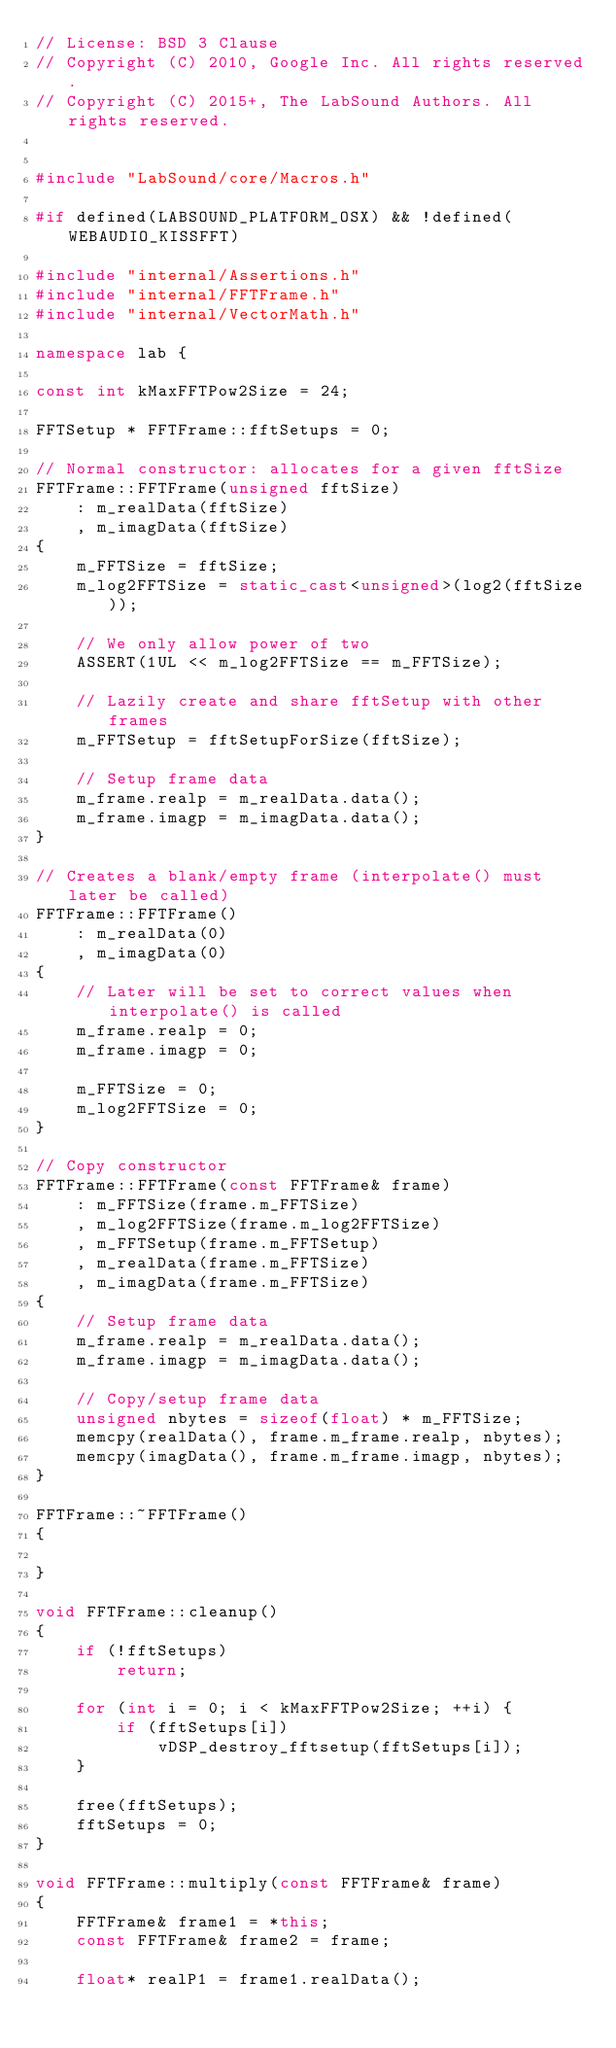<code> <loc_0><loc_0><loc_500><loc_500><_C++_>// License: BSD 3 Clause
// Copyright (C) 2010, Google Inc. All rights reserved.
// Copyright (C) 2015+, The LabSound Authors. All rights reserved.


#include "LabSound/core/Macros.h"

#if defined(LABSOUND_PLATFORM_OSX) && !defined(WEBAUDIO_KISSFFT)

#include "internal/Assertions.h"
#include "internal/FFTFrame.h"
#include "internal/VectorMath.h"

namespace lab {

const int kMaxFFTPow2Size = 24;

FFTSetup * FFTFrame::fftSetups = 0;

// Normal constructor: allocates for a given fftSize
FFTFrame::FFTFrame(unsigned fftSize)
    : m_realData(fftSize)
    , m_imagData(fftSize)
{
    m_FFTSize = fftSize;
    m_log2FFTSize = static_cast<unsigned>(log2(fftSize));

    // We only allow power of two
    ASSERT(1UL << m_log2FFTSize == m_FFTSize);

    // Lazily create and share fftSetup with other frames
    m_FFTSetup = fftSetupForSize(fftSize);

    // Setup frame data
    m_frame.realp = m_realData.data();
    m_frame.imagp = m_imagData.data();
}

// Creates a blank/empty frame (interpolate() must later be called)
FFTFrame::FFTFrame()
    : m_realData(0)
    , m_imagData(0)
{
    // Later will be set to correct values when interpolate() is called
    m_frame.realp = 0;
    m_frame.imagp = 0;

    m_FFTSize = 0;
    m_log2FFTSize = 0;
}

// Copy constructor
FFTFrame::FFTFrame(const FFTFrame& frame)
    : m_FFTSize(frame.m_FFTSize)
    , m_log2FFTSize(frame.m_log2FFTSize)
    , m_FFTSetup(frame.m_FFTSetup)
    , m_realData(frame.m_FFTSize)
    , m_imagData(frame.m_FFTSize)
{
    // Setup frame data
    m_frame.realp = m_realData.data();
    m_frame.imagp = m_imagData.data();

    // Copy/setup frame data
    unsigned nbytes = sizeof(float) * m_FFTSize;
    memcpy(realData(), frame.m_frame.realp, nbytes);
    memcpy(imagData(), frame.m_frame.imagp, nbytes);
}

FFTFrame::~FFTFrame()
{

}
    
void FFTFrame::cleanup()
{
    if (!fftSetups)
        return;
    
    for (int i = 0; i < kMaxFFTPow2Size; ++i) {
        if (fftSetups[i])
            vDSP_destroy_fftsetup(fftSetups[i]);
    }
    
    free(fftSetups);
    fftSetups = 0;
}
    
void FFTFrame::multiply(const FFTFrame& frame)
{
    FFTFrame& frame1 = *this;
    const FFTFrame& frame2 = frame;

    float* realP1 = frame1.realData();</code> 